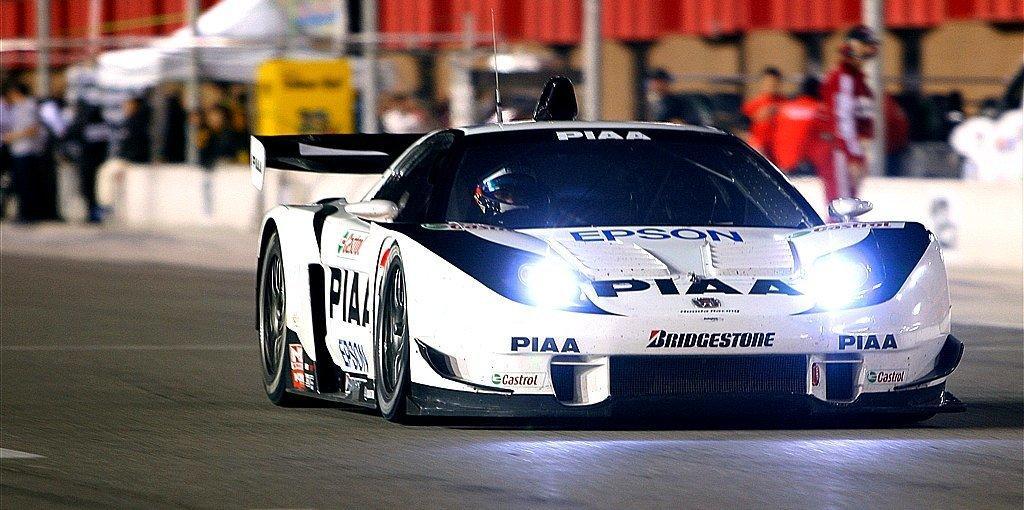Can you describe this image briefly? In this picture there is a car on the road and there is a person sitting inside the car and there is text on the car. At the back there is a building and there are group of people and there is a tent and there is a board and there is text on the board. At the bottom there is a road. 